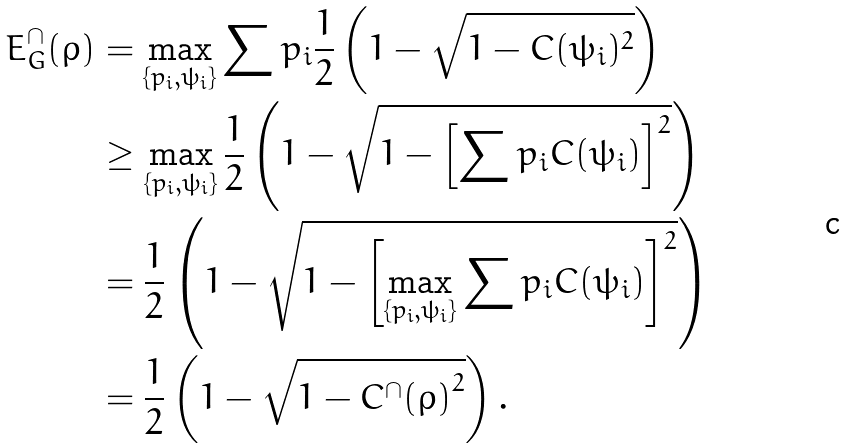Convert formula to latex. <formula><loc_0><loc_0><loc_500><loc_500>E _ { G } ^ { \cap } ( \rho ) & = \max _ { \{ p _ { i } , \psi _ { i } \} } \sum p _ { i } \frac { 1 } { 2 } \left ( 1 - \sqrt { 1 - C ( \psi _ { i } ) ^ { 2 } } \right ) \\ & \geq \max _ { \{ p _ { i } , \psi _ { i } \} } \frac { 1 } { 2 } \left ( 1 - \sqrt { 1 - \left [ \sum p _ { i } C ( \psi _ { i } ) \right ] ^ { 2 } } \right ) \\ & = \frac { 1 } { 2 } \left ( 1 - \sqrt { 1 - \left [ \max _ { \{ p _ { i } , \psi _ { i } \} } \sum p _ { i } C ( \psi _ { i } ) \right ] ^ { 2 } } \right ) \\ & = \frac { 1 } { 2 } \left ( 1 - \sqrt { 1 - { C ^ { \cap } ( \rho ) } ^ { 2 } } \right ) .</formula> 